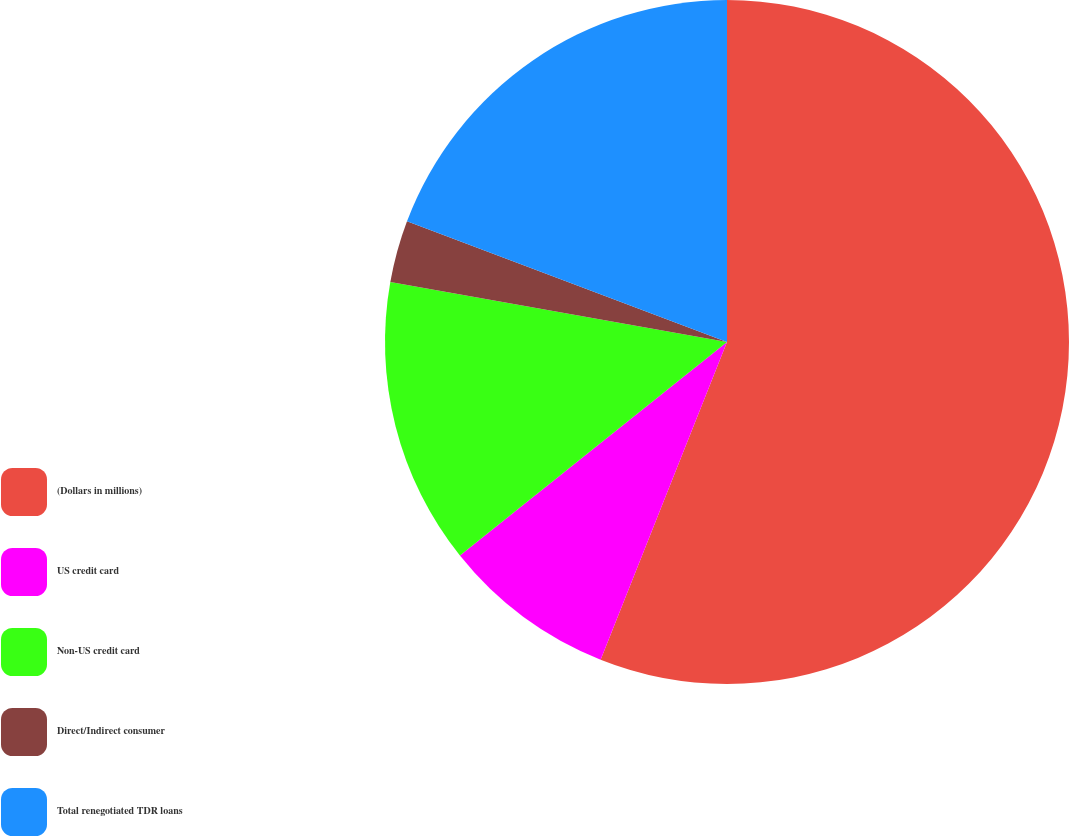<chart> <loc_0><loc_0><loc_500><loc_500><pie_chart><fcel>(Dollars in millions)<fcel>US credit card<fcel>Non-US credit card<fcel>Direct/Indirect consumer<fcel>Total renegotiated TDR loans<nl><fcel>56.03%<fcel>8.24%<fcel>13.55%<fcel>2.93%<fcel>19.26%<nl></chart> 